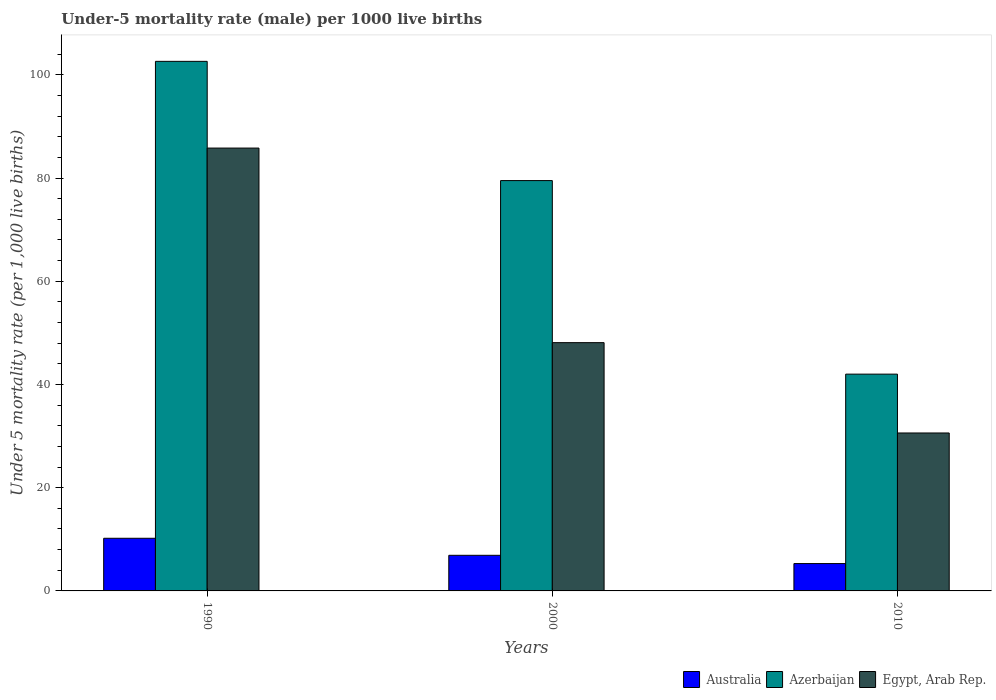Are the number of bars per tick equal to the number of legend labels?
Provide a short and direct response. Yes. How many bars are there on the 2nd tick from the left?
Keep it short and to the point. 3. How many bars are there on the 1st tick from the right?
Make the answer very short. 3. Across all years, what is the maximum under-five mortality rate in Azerbaijan?
Provide a succinct answer. 102.6. In which year was the under-five mortality rate in Australia maximum?
Your answer should be compact. 1990. What is the total under-five mortality rate in Australia in the graph?
Keep it short and to the point. 22.4. What is the difference between the under-five mortality rate in Australia in 2000 and that in 2010?
Your response must be concise. 1.6. What is the difference between the under-five mortality rate in Australia in 2010 and the under-five mortality rate in Egypt, Arab Rep. in 1990?
Offer a very short reply. -80.5. What is the average under-five mortality rate in Egypt, Arab Rep. per year?
Your answer should be very brief. 54.83. In the year 2010, what is the difference between the under-five mortality rate in Azerbaijan and under-five mortality rate in Egypt, Arab Rep.?
Provide a succinct answer. 11.4. In how many years, is the under-five mortality rate in Egypt, Arab Rep. greater than 56?
Offer a terse response. 1. What is the ratio of the under-five mortality rate in Australia in 2000 to that in 2010?
Keep it short and to the point. 1.3. Is the under-five mortality rate in Australia in 2000 less than that in 2010?
Offer a very short reply. No. What is the difference between the highest and the second highest under-five mortality rate in Egypt, Arab Rep.?
Give a very brief answer. 37.7. What is the difference between the highest and the lowest under-five mortality rate in Egypt, Arab Rep.?
Offer a terse response. 55.2. In how many years, is the under-five mortality rate in Australia greater than the average under-five mortality rate in Australia taken over all years?
Offer a terse response. 1. What does the 2nd bar from the left in 2000 represents?
Make the answer very short. Azerbaijan. Are all the bars in the graph horizontal?
Your response must be concise. No. What is the difference between two consecutive major ticks on the Y-axis?
Offer a very short reply. 20. Are the values on the major ticks of Y-axis written in scientific E-notation?
Your response must be concise. No. Does the graph contain any zero values?
Make the answer very short. No. Does the graph contain grids?
Offer a terse response. No. How many legend labels are there?
Your answer should be very brief. 3. How are the legend labels stacked?
Ensure brevity in your answer.  Horizontal. What is the title of the graph?
Provide a short and direct response. Under-5 mortality rate (male) per 1000 live births. What is the label or title of the X-axis?
Offer a terse response. Years. What is the label or title of the Y-axis?
Your response must be concise. Under 5 mortality rate (per 1,0 live births). What is the Under 5 mortality rate (per 1,000 live births) in Azerbaijan in 1990?
Give a very brief answer. 102.6. What is the Under 5 mortality rate (per 1,000 live births) of Egypt, Arab Rep. in 1990?
Your answer should be very brief. 85.8. What is the Under 5 mortality rate (per 1,000 live births) in Azerbaijan in 2000?
Keep it short and to the point. 79.5. What is the Under 5 mortality rate (per 1,000 live births) of Egypt, Arab Rep. in 2000?
Keep it short and to the point. 48.1. What is the Under 5 mortality rate (per 1,000 live births) in Egypt, Arab Rep. in 2010?
Offer a very short reply. 30.6. Across all years, what is the maximum Under 5 mortality rate (per 1,000 live births) in Australia?
Give a very brief answer. 10.2. Across all years, what is the maximum Under 5 mortality rate (per 1,000 live births) in Azerbaijan?
Provide a short and direct response. 102.6. Across all years, what is the maximum Under 5 mortality rate (per 1,000 live births) of Egypt, Arab Rep.?
Your answer should be very brief. 85.8. Across all years, what is the minimum Under 5 mortality rate (per 1,000 live births) of Azerbaijan?
Offer a very short reply. 42. Across all years, what is the minimum Under 5 mortality rate (per 1,000 live births) in Egypt, Arab Rep.?
Provide a succinct answer. 30.6. What is the total Under 5 mortality rate (per 1,000 live births) in Australia in the graph?
Your answer should be very brief. 22.4. What is the total Under 5 mortality rate (per 1,000 live births) in Azerbaijan in the graph?
Make the answer very short. 224.1. What is the total Under 5 mortality rate (per 1,000 live births) of Egypt, Arab Rep. in the graph?
Provide a short and direct response. 164.5. What is the difference between the Under 5 mortality rate (per 1,000 live births) in Azerbaijan in 1990 and that in 2000?
Keep it short and to the point. 23.1. What is the difference between the Under 5 mortality rate (per 1,000 live births) of Egypt, Arab Rep. in 1990 and that in 2000?
Offer a terse response. 37.7. What is the difference between the Under 5 mortality rate (per 1,000 live births) of Azerbaijan in 1990 and that in 2010?
Offer a very short reply. 60.6. What is the difference between the Under 5 mortality rate (per 1,000 live births) of Egypt, Arab Rep. in 1990 and that in 2010?
Provide a short and direct response. 55.2. What is the difference between the Under 5 mortality rate (per 1,000 live births) in Australia in 2000 and that in 2010?
Provide a succinct answer. 1.6. What is the difference between the Under 5 mortality rate (per 1,000 live births) in Azerbaijan in 2000 and that in 2010?
Your answer should be compact. 37.5. What is the difference between the Under 5 mortality rate (per 1,000 live births) of Australia in 1990 and the Under 5 mortality rate (per 1,000 live births) of Azerbaijan in 2000?
Your response must be concise. -69.3. What is the difference between the Under 5 mortality rate (per 1,000 live births) of Australia in 1990 and the Under 5 mortality rate (per 1,000 live births) of Egypt, Arab Rep. in 2000?
Keep it short and to the point. -37.9. What is the difference between the Under 5 mortality rate (per 1,000 live births) of Azerbaijan in 1990 and the Under 5 mortality rate (per 1,000 live births) of Egypt, Arab Rep. in 2000?
Provide a short and direct response. 54.5. What is the difference between the Under 5 mortality rate (per 1,000 live births) of Australia in 1990 and the Under 5 mortality rate (per 1,000 live births) of Azerbaijan in 2010?
Provide a succinct answer. -31.8. What is the difference between the Under 5 mortality rate (per 1,000 live births) of Australia in 1990 and the Under 5 mortality rate (per 1,000 live births) of Egypt, Arab Rep. in 2010?
Your response must be concise. -20.4. What is the difference between the Under 5 mortality rate (per 1,000 live births) in Australia in 2000 and the Under 5 mortality rate (per 1,000 live births) in Azerbaijan in 2010?
Your answer should be very brief. -35.1. What is the difference between the Under 5 mortality rate (per 1,000 live births) in Australia in 2000 and the Under 5 mortality rate (per 1,000 live births) in Egypt, Arab Rep. in 2010?
Your response must be concise. -23.7. What is the difference between the Under 5 mortality rate (per 1,000 live births) in Azerbaijan in 2000 and the Under 5 mortality rate (per 1,000 live births) in Egypt, Arab Rep. in 2010?
Offer a terse response. 48.9. What is the average Under 5 mortality rate (per 1,000 live births) in Australia per year?
Offer a very short reply. 7.47. What is the average Under 5 mortality rate (per 1,000 live births) of Azerbaijan per year?
Ensure brevity in your answer.  74.7. What is the average Under 5 mortality rate (per 1,000 live births) of Egypt, Arab Rep. per year?
Offer a very short reply. 54.83. In the year 1990, what is the difference between the Under 5 mortality rate (per 1,000 live births) in Australia and Under 5 mortality rate (per 1,000 live births) in Azerbaijan?
Your response must be concise. -92.4. In the year 1990, what is the difference between the Under 5 mortality rate (per 1,000 live births) in Australia and Under 5 mortality rate (per 1,000 live births) in Egypt, Arab Rep.?
Your answer should be compact. -75.6. In the year 2000, what is the difference between the Under 5 mortality rate (per 1,000 live births) of Australia and Under 5 mortality rate (per 1,000 live births) of Azerbaijan?
Your answer should be very brief. -72.6. In the year 2000, what is the difference between the Under 5 mortality rate (per 1,000 live births) in Australia and Under 5 mortality rate (per 1,000 live births) in Egypt, Arab Rep.?
Offer a terse response. -41.2. In the year 2000, what is the difference between the Under 5 mortality rate (per 1,000 live births) of Azerbaijan and Under 5 mortality rate (per 1,000 live births) of Egypt, Arab Rep.?
Your answer should be very brief. 31.4. In the year 2010, what is the difference between the Under 5 mortality rate (per 1,000 live births) in Australia and Under 5 mortality rate (per 1,000 live births) in Azerbaijan?
Give a very brief answer. -36.7. In the year 2010, what is the difference between the Under 5 mortality rate (per 1,000 live births) in Australia and Under 5 mortality rate (per 1,000 live births) in Egypt, Arab Rep.?
Ensure brevity in your answer.  -25.3. In the year 2010, what is the difference between the Under 5 mortality rate (per 1,000 live births) in Azerbaijan and Under 5 mortality rate (per 1,000 live births) in Egypt, Arab Rep.?
Your response must be concise. 11.4. What is the ratio of the Under 5 mortality rate (per 1,000 live births) of Australia in 1990 to that in 2000?
Make the answer very short. 1.48. What is the ratio of the Under 5 mortality rate (per 1,000 live births) of Azerbaijan in 1990 to that in 2000?
Your answer should be compact. 1.29. What is the ratio of the Under 5 mortality rate (per 1,000 live births) in Egypt, Arab Rep. in 1990 to that in 2000?
Offer a terse response. 1.78. What is the ratio of the Under 5 mortality rate (per 1,000 live births) in Australia in 1990 to that in 2010?
Keep it short and to the point. 1.92. What is the ratio of the Under 5 mortality rate (per 1,000 live births) in Azerbaijan in 1990 to that in 2010?
Offer a very short reply. 2.44. What is the ratio of the Under 5 mortality rate (per 1,000 live births) of Egypt, Arab Rep. in 1990 to that in 2010?
Your answer should be compact. 2.8. What is the ratio of the Under 5 mortality rate (per 1,000 live births) of Australia in 2000 to that in 2010?
Your response must be concise. 1.3. What is the ratio of the Under 5 mortality rate (per 1,000 live births) in Azerbaijan in 2000 to that in 2010?
Provide a short and direct response. 1.89. What is the ratio of the Under 5 mortality rate (per 1,000 live births) of Egypt, Arab Rep. in 2000 to that in 2010?
Keep it short and to the point. 1.57. What is the difference between the highest and the second highest Under 5 mortality rate (per 1,000 live births) of Australia?
Your answer should be compact. 3.3. What is the difference between the highest and the second highest Under 5 mortality rate (per 1,000 live births) in Azerbaijan?
Offer a terse response. 23.1. What is the difference between the highest and the second highest Under 5 mortality rate (per 1,000 live births) in Egypt, Arab Rep.?
Provide a succinct answer. 37.7. What is the difference between the highest and the lowest Under 5 mortality rate (per 1,000 live births) in Australia?
Keep it short and to the point. 4.9. What is the difference between the highest and the lowest Under 5 mortality rate (per 1,000 live births) of Azerbaijan?
Provide a succinct answer. 60.6. What is the difference between the highest and the lowest Under 5 mortality rate (per 1,000 live births) of Egypt, Arab Rep.?
Offer a very short reply. 55.2. 